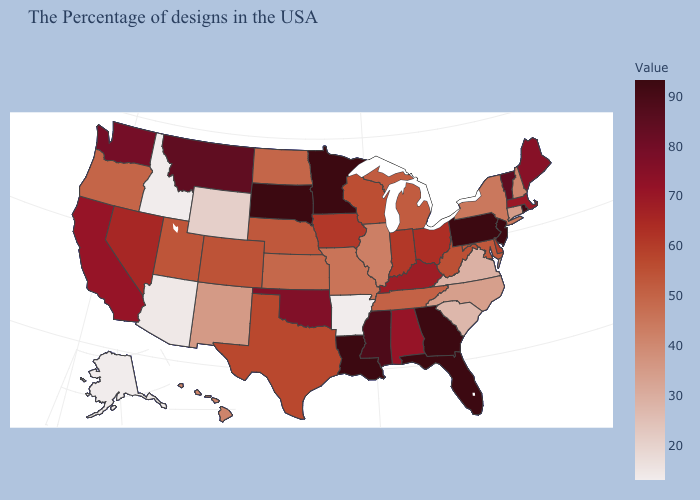Which states have the lowest value in the USA?
Concise answer only. Arkansas, Idaho, Alaska. Which states have the lowest value in the USA?
Write a very short answer. Arkansas, Idaho, Alaska. Which states hav the highest value in the MidWest?
Concise answer only. Minnesota, South Dakota. 